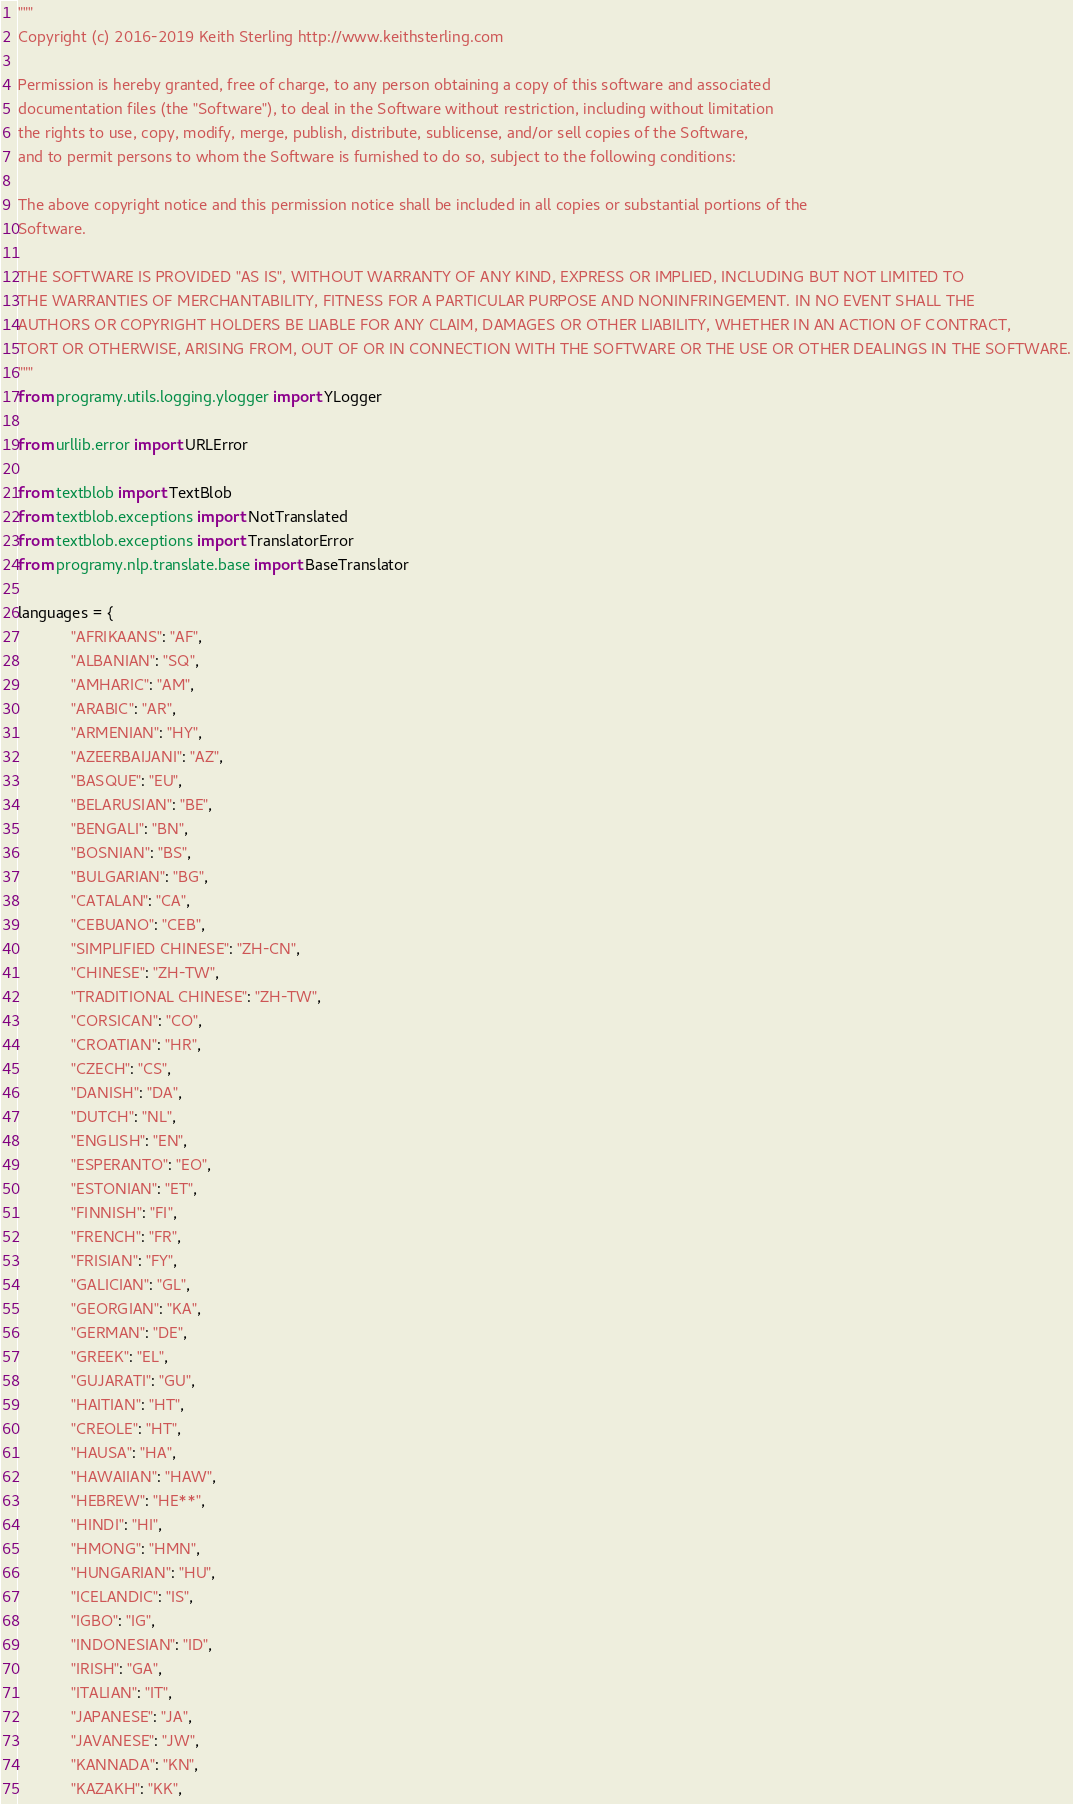<code> <loc_0><loc_0><loc_500><loc_500><_Python_>"""
Copyright (c) 2016-2019 Keith Sterling http://www.keithsterling.com

Permission is hereby granted, free of charge, to any person obtaining a copy of this software and associated
documentation files (the "Software"), to deal in the Software without restriction, including without limitation
the rights to use, copy, modify, merge, publish, distribute, sublicense, and/or sell copies of the Software,
and to permit persons to whom the Software is furnished to do so, subject to the following conditions:

The above copyright notice and this permission notice shall be included in all copies or substantial portions of the
Software.

THE SOFTWARE IS PROVIDED "AS IS", WITHOUT WARRANTY OF ANY KIND, EXPRESS OR IMPLIED, INCLUDING BUT NOT LIMITED TO
THE WARRANTIES OF MERCHANTABILITY, FITNESS FOR A PARTICULAR PURPOSE AND NONINFRINGEMENT. IN NO EVENT SHALL THE
AUTHORS OR COPYRIGHT HOLDERS BE LIABLE FOR ANY CLAIM, DAMAGES OR OTHER LIABILITY, WHETHER IN AN ACTION OF CONTRACT,
TORT OR OTHERWISE, ARISING FROM, OUT OF OR IN CONNECTION WITH THE SOFTWARE OR THE USE OR OTHER DEALINGS IN THE SOFTWARE.
"""
from programy.utils.logging.ylogger import YLogger

from urllib.error import URLError

from textblob import TextBlob
from textblob.exceptions import NotTranslated
from textblob.exceptions import TranslatorError
from programy.nlp.translate.base import BaseTranslator

languages = {
            "AFRIKAANS": "AF",
            "ALBANIAN": "SQ",
            "AMHARIC": "AM",
            "ARABIC": "AR",
            "ARMENIAN": "HY",
            "AZEERBAIJANI": "AZ",
            "BASQUE": "EU",
            "BELARUSIAN": "BE",
            "BENGALI": "BN",
            "BOSNIAN": "BS",
            "BULGARIAN": "BG",
            "CATALAN": "CA",
            "CEBUANO": "CEB",
            "SIMPLIFIED CHINESE": "ZH-CN",
            "CHINESE": "ZH-TW",
            "TRADITIONAL CHINESE": "ZH-TW",
            "CORSICAN": "CO",
            "CROATIAN": "HR",
            "CZECH": "CS",
            "DANISH": "DA",
            "DUTCH": "NL",
            "ENGLISH": "EN",
            "ESPERANTO": "EO",
            "ESTONIAN": "ET",
            "FINNISH": "FI",
            "FRENCH": "FR",
            "FRISIAN": "FY",
            "GALICIAN": "GL",
            "GEORGIAN": "KA",
            "GERMAN": "DE",
            "GREEK": "EL",
            "GUJARATI": "GU",
            "HAITIAN": "HT",
            "CREOLE": "HT",
            "HAUSA": "HA",
            "HAWAIIAN": "HAW",
            "HEBREW": "HE**",
            "HINDI": "HI",
            "HMONG": "HMN",
            "HUNGARIAN": "HU",
            "ICELANDIC": "IS",
            "IGBO": "IG",
            "INDONESIAN": "ID",
            "IRISH": "GA",
            "ITALIAN": "IT",
            "JAPANESE": "JA",
            "JAVANESE": "JW",
            "KANNADA": "KN",
            "KAZAKH": "KK",</code> 